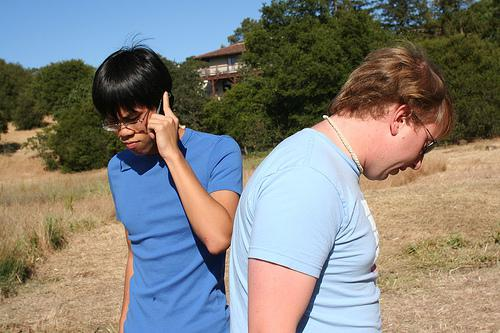Question: what is in the background?
Choices:
A. Just trees.
B. Just a house.
C. Trees and a house.
D. Shrubs and a house.
Answer with the letter. Answer: C Question: who is on the cell phone?
Choices:
A. The man with brown hair.
B. The woman with black hair.
C. The man with black hair.
D. The woman with brown hair.
Answer with the letter. Answer: C Question: what is on the men's faces?
Choices:
A. Goggles.
B. Glasses.
C. Monocles.
D. Eyepatches.
Answer with the letter. Answer: B Question: where are the men?
Choices:
A. In a field.
B. In a forest.
C. In a city.
D. At the beach.
Answer with the letter. Answer: A 